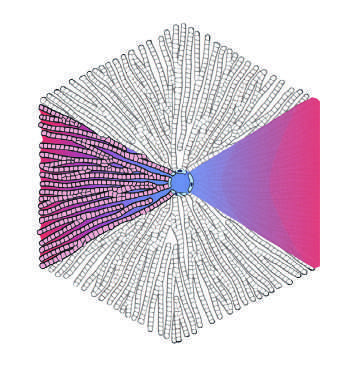s remote kidney infarct at the center of a lobule, while the portal tracts are at the periphery in the lobular model?
Answer the question using a single word or phrase. No 